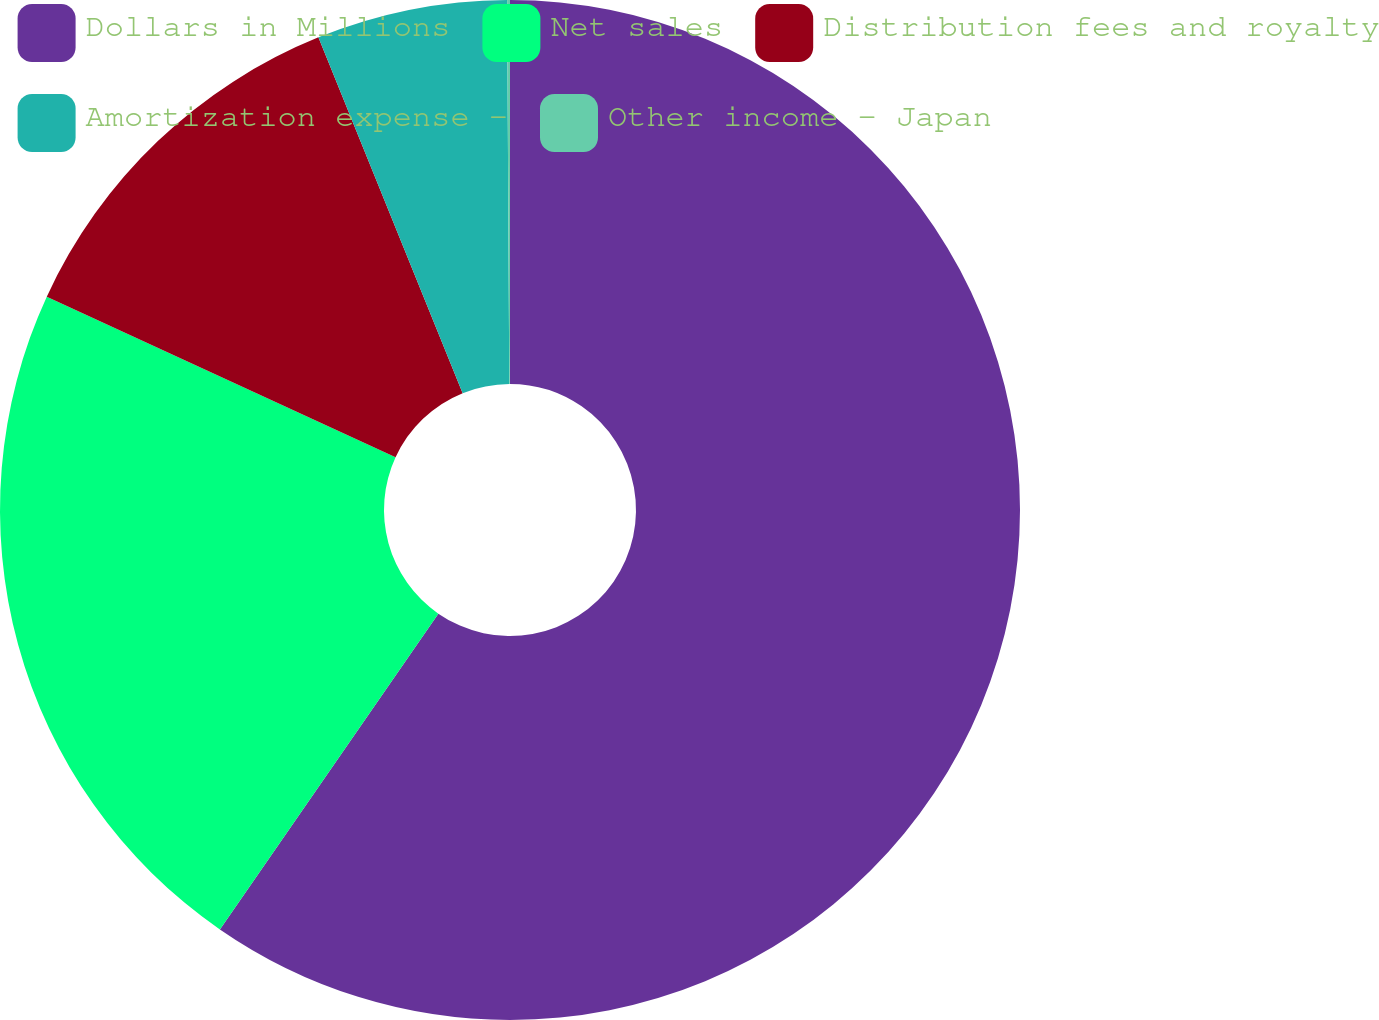Convert chart to OTSL. <chart><loc_0><loc_0><loc_500><loc_500><pie_chart><fcel>Dollars in Millions<fcel>Net sales<fcel>Distribution fees and royalty<fcel>Amortization expense -<fcel>Other income - Japan<nl><fcel>59.63%<fcel>22.24%<fcel>12.0%<fcel>6.04%<fcel>0.09%<nl></chart> 